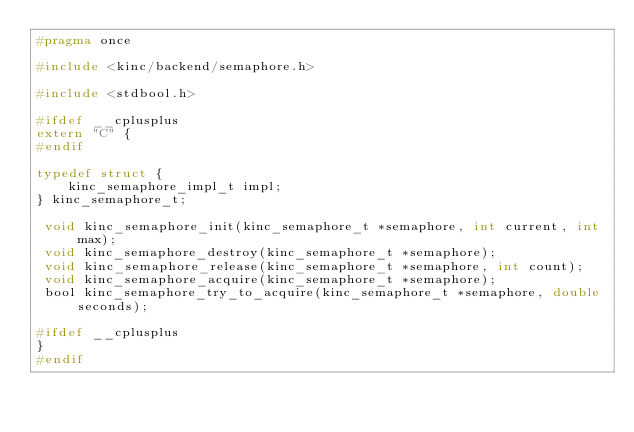Convert code to text. <code><loc_0><loc_0><loc_500><loc_500><_C_>#pragma once

#include <kinc/backend/semaphore.h>

#include <stdbool.h>

#ifdef __cplusplus
extern "C" {
#endif

typedef struct {
	kinc_semaphore_impl_t impl;
} kinc_semaphore_t;

 void kinc_semaphore_init(kinc_semaphore_t *semaphore, int current, int max);
 void kinc_semaphore_destroy(kinc_semaphore_t *semaphore);
 void kinc_semaphore_release(kinc_semaphore_t *semaphore, int count);
 void kinc_semaphore_acquire(kinc_semaphore_t *semaphore);
 bool kinc_semaphore_try_to_acquire(kinc_semaphore_t *semaphore, double seconds);

#ifdef __cplusplus
}
#endif
</code> 